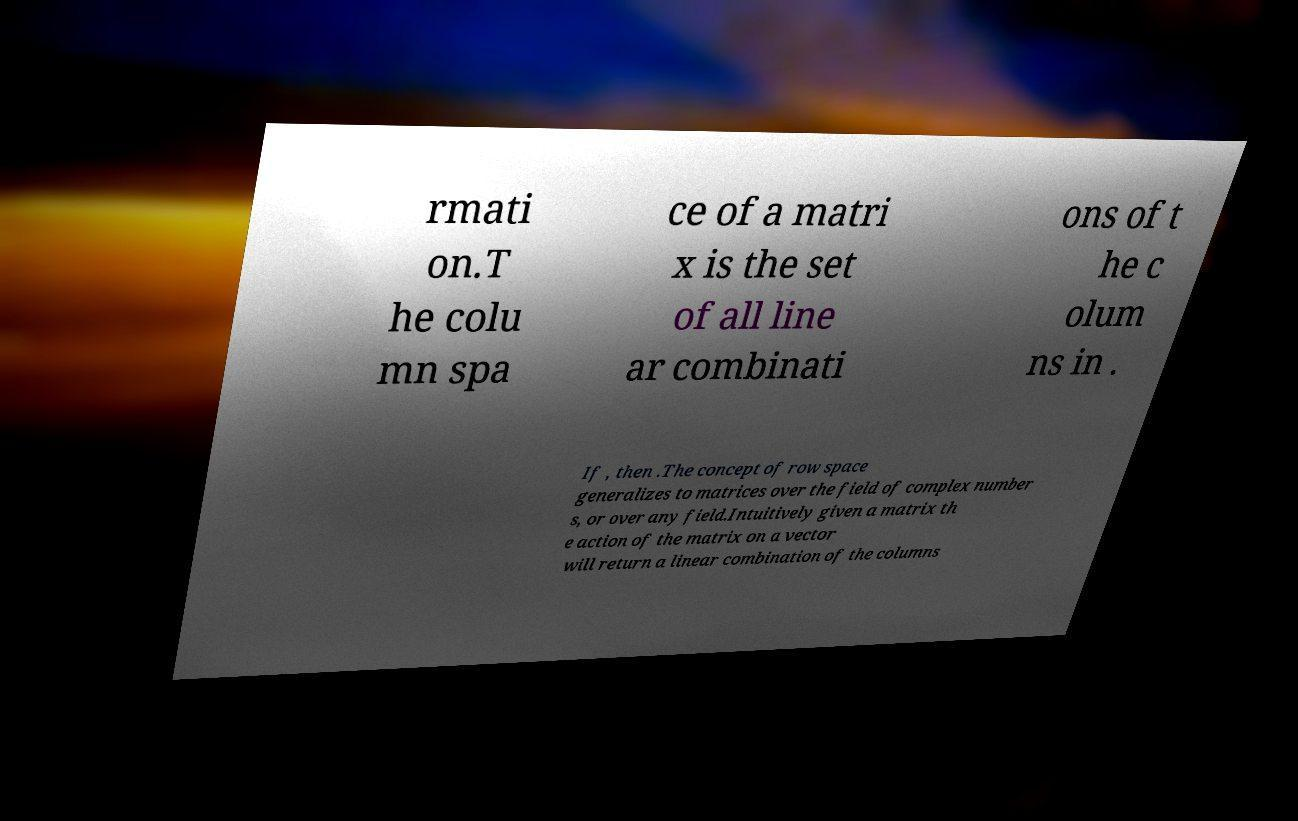For documentation purposes, I need the text within this image transcribed. Could you provide that? rmati on.T he colu mn spa ce of a matri x is the set of all line ar combinati ons of t he c olum ns in . If , then .The concept of row space generalizes to matrices over the field of complex number s, or over any field.Intuitively given a matrix th e action of the matrix on a vector will return a linear combination of the columns 